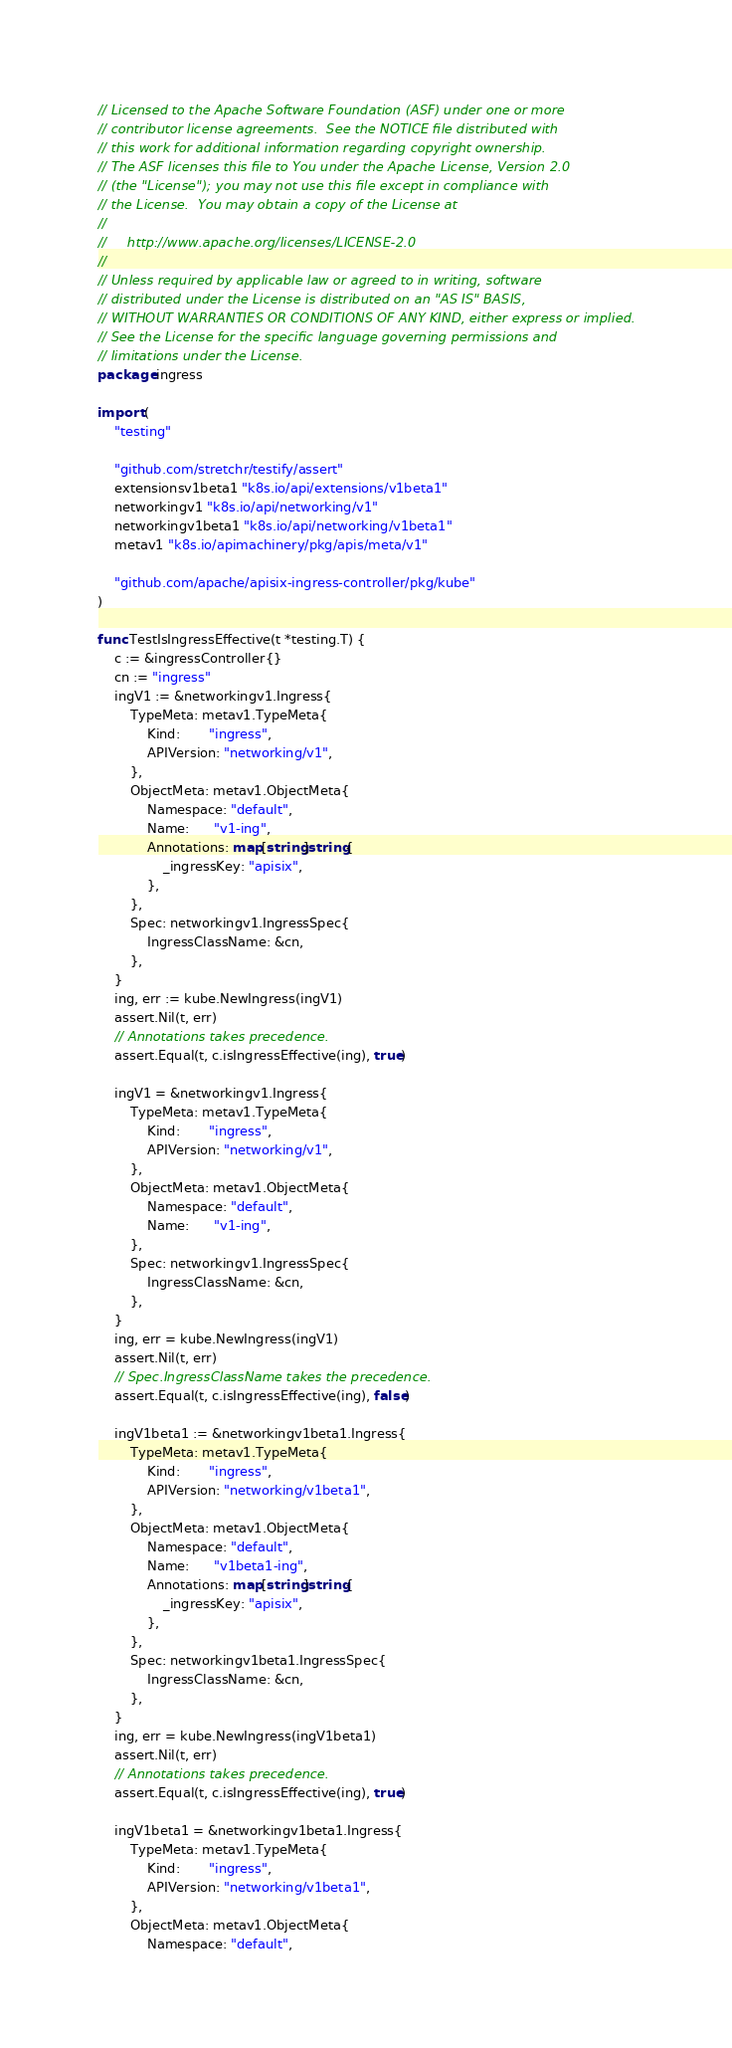Convert code to text. <code><loc_0><loc_0><loc_500><loc_500><_Go_>// Licensed to the Apache Software Foundation (ASF) under one or more
// contributor license agreements.  See the NOTICE file distributed with
// this work for additional information regarding copyright ownership.
// The ASF licenses this file to You under the Apache License, Version 2.0
// (the "License"); you may not use this file except in compliance with
// the License.  You may obtain a copy of the License at
//
//     http://www.apache.org/licenses/LICENSE-2.0
//
// Unless required by applicable law or agreed to in writing, software
// distributed under the License is distributed on an "AS IS" BASIS,
// WITHOUT WARRANTIES OR CONDITIONS OF ANY KIND, either express or implied.
// See the License for the specific language governing permissions and
// limitations under the License.
package ingress

import (
	"testing"

	"github.com/stretchr/testify/assert"
	extensionsv1beta1 "k8s.io/api/extensions/v1beta1"
	networkingv1 "k8s.io/api/networking/v1"
	networkingv1beta1 "k8s.io/api/networking/v1beta1"
	metav1 "k8s.io/apimachinery/pkg/apis/meta/v1"

	"github.com/apache/apisix-ingress-controller/pkg/kube"
)

func TestIsIngressEffective(t *testing.T) {
	c := &ingressController{}
	cn := "ingress"
	ingV1 := &networkingv1.Ingress{
		TypeMeta: metav1.TypeMeta{
			Kind:       "ingress",
			APIVersion: "networking/v1",
		},
		ObjectMeta: metav1.ObjectMeta{
			Namespace: "default",
			Name:      "v1-ing",
			Annotations: map[string]string{
				_ingressKey: "apisix",
			},
		},
		Spec: networkingv1.IngressSpec{
			IngressClassName: &cn,
		},
	}
	ing, err := kube.NewIngress(ingV1)
	assert.Nil(t, err)
	// Annotations takes precedence.
	assert.Equal(t, c.isIngressEffective(ing), true)

	ingV1 = &networkingv1.Ingress{
		TypeMeta: metav1.TypeMeta{
			Kind:       "ingress",
			APIVersion: "networking/v1",
		},
		ObjectMeta: metav1.ObjectMeta{
			Namespace: "default",
			Name:      "v1-ing",
		},
		Spec: networkingv1.IngressSpec{
			IngressClassName: &cn,
		},
	}
	ing, err = kube.NewIngress(ingV1)
	assert.Nil(t, err)
	// Spec.IngressClassName takes the precedence.
	assert.Equal(t, c.isIngressEffective(ing), false)

	ingV1beta1 := &networkingv1beta1.Ingress{
		TypeMeta: metav1.TypeMeta{
			Kind:       "ingress",
			APIVersion: "networking/v1beta1",
		},
		ObjectMeta: metav1.ObjectMeta{
			Namespace: "default",
			Name:      "v1beta1-ing",
			Annotations: map[string]string{
				_ingressKey: "apisix",
			},
		},
		Spec: networkingv1beta1.IngressSpec{
			IngressClassName: &cn,
		},
	}
	ing, err = kube.NewIngress(ingV1beta1)
	assert.Nil(t, err)
	// Annotations takes precedence.
	assert.Equal(t, c.isIngressEffective(ing), true)

	ingV1beta1 = &networkingv1beta1.Ingress{
		TypeMeta: metav1.TypeMeta{
			Kind:       "ingress",
			APIVersion: "networking/v1beta1",
		},
		ObjectMeta: metav1.ObjectMeta{
			Namespace: "default",</code> 